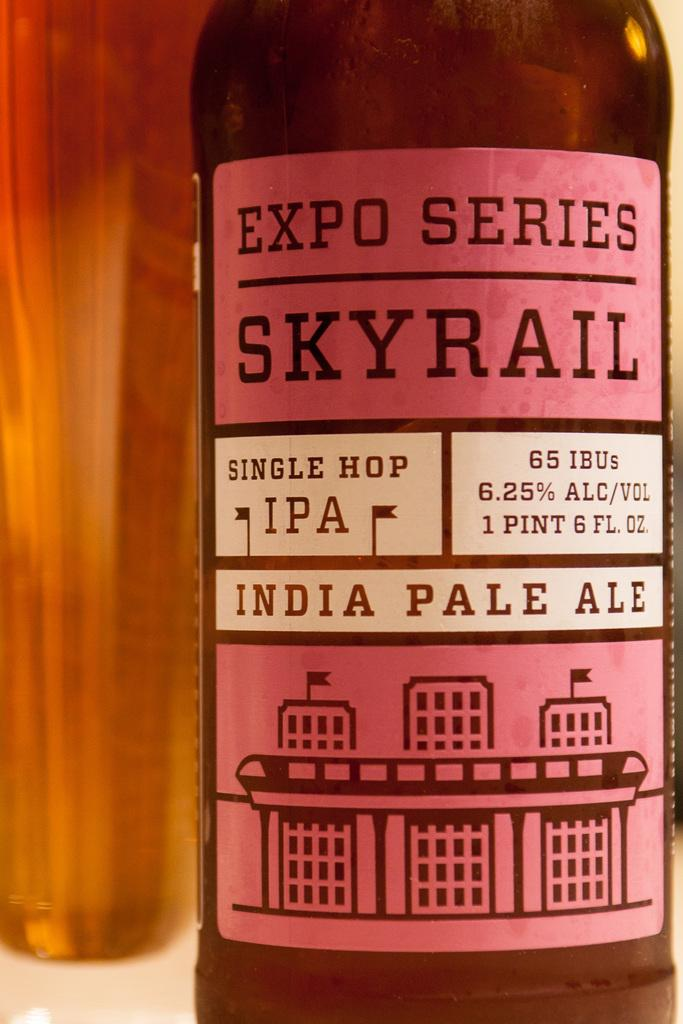<image>
Write a terse but informative summary of the picture. A beer bottle is filled with delicious India pale ale. 